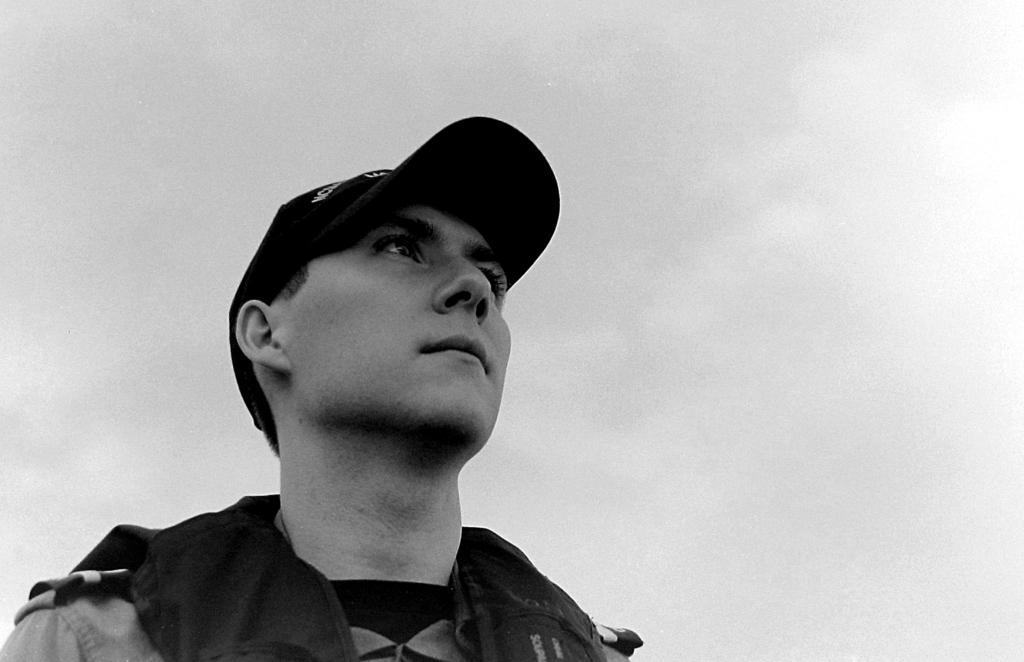Please provide a concise description of this image. In this picture I can see a man in front who is wearing a cap on his head and in the background I see the sky and I see that this is a white and black image. 